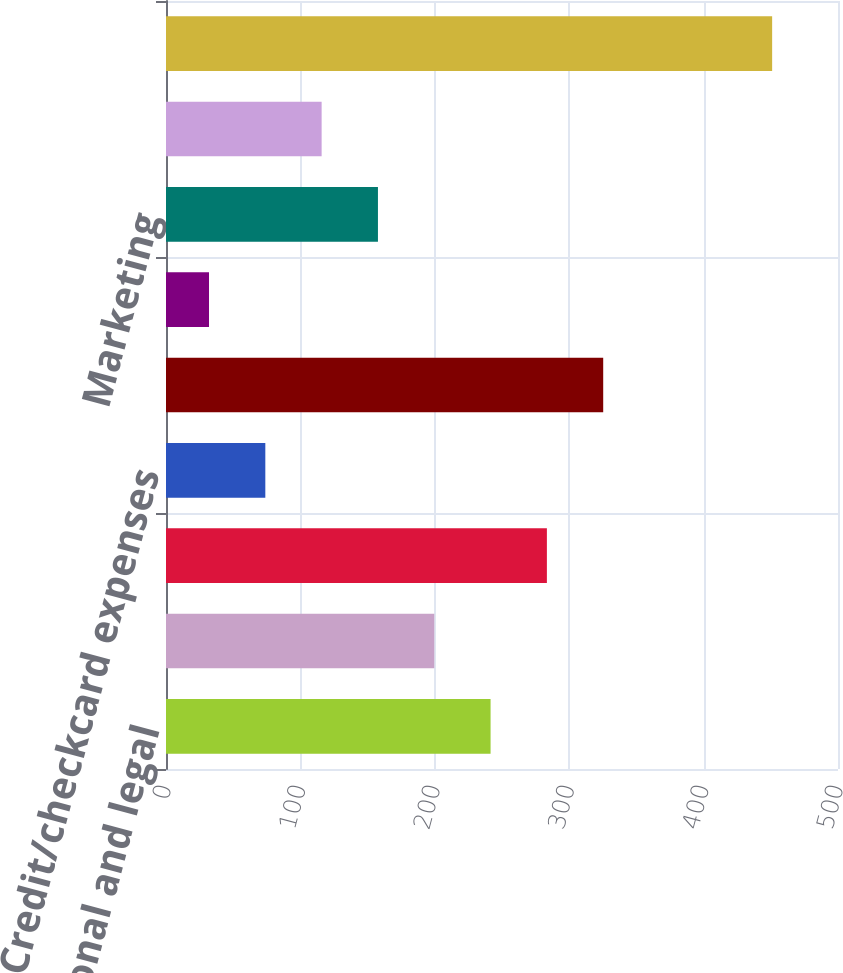<chart> <loc_0><loc_0><loc_500><loc_500><bar_chart><fcel>Professional and legal<fcel>Amortization of core deposit<fcel>Other real estate owned<fcel>Credit/checkcard expenses<fcel>Deposit administrative fee<fcel>(Gain)/loss on loans held for<fcel>Marketing<fcel>Outside services<fcel>Other miscellaneous expenses<nl><fcel>241.5<fcel>199.6<fcel>283.4<fcel>73.9<fcel>325.3<fcel>32<fcel>157.7<fcel>115.8<fcel>451<nl></chart> 